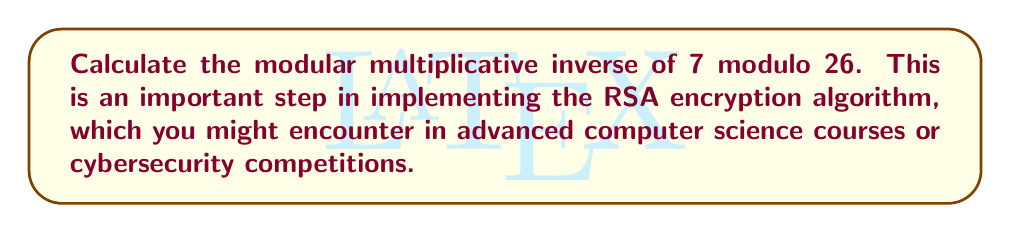Help me with this question. To find the modular multiplicative inverse of 7 modulo 26, we need to find a number $x$ such that:

$$(7x) \equiv 1 \pmod{26}$$

We can solve this using the Extended Euclidean Algorithm:

1) First, let's set up the initial values:
   $26 = 3 \times 7 + 5$
   $7 = 1 \times 5 + 2$
   $5 = 2 \times 2 + 1$
   $2 = 2 \times 1 + 0$

2) Now, we work backwards:
   $1 = 5 - 2 \times 2$
   $1 = 5 - 2 \times (7 - 1 \times 5) = 3 \times 5 - 2 \times 7$
   $1 = 3 \times (26 - 3 \times 7) - 2 \times 7 = 3 \times 26 - 11 \times 7$

3) Therefore:
   $11 \times 7 \equiv -1 \pmod{26}$
   $-11 \times 7 \equiv 1 \pmod{26}$

4) Since we want a positive number less than 26, we add 26 to -11:
   $15 \times 7 \equiv 1 \pmod{26}$

Thus, 15 is the modular multiplicative inverse of 7 modulo 26.

You can verify this: $15 \times 7 = 105 \equiv 1 \pmod{26}$
Answer: 15 